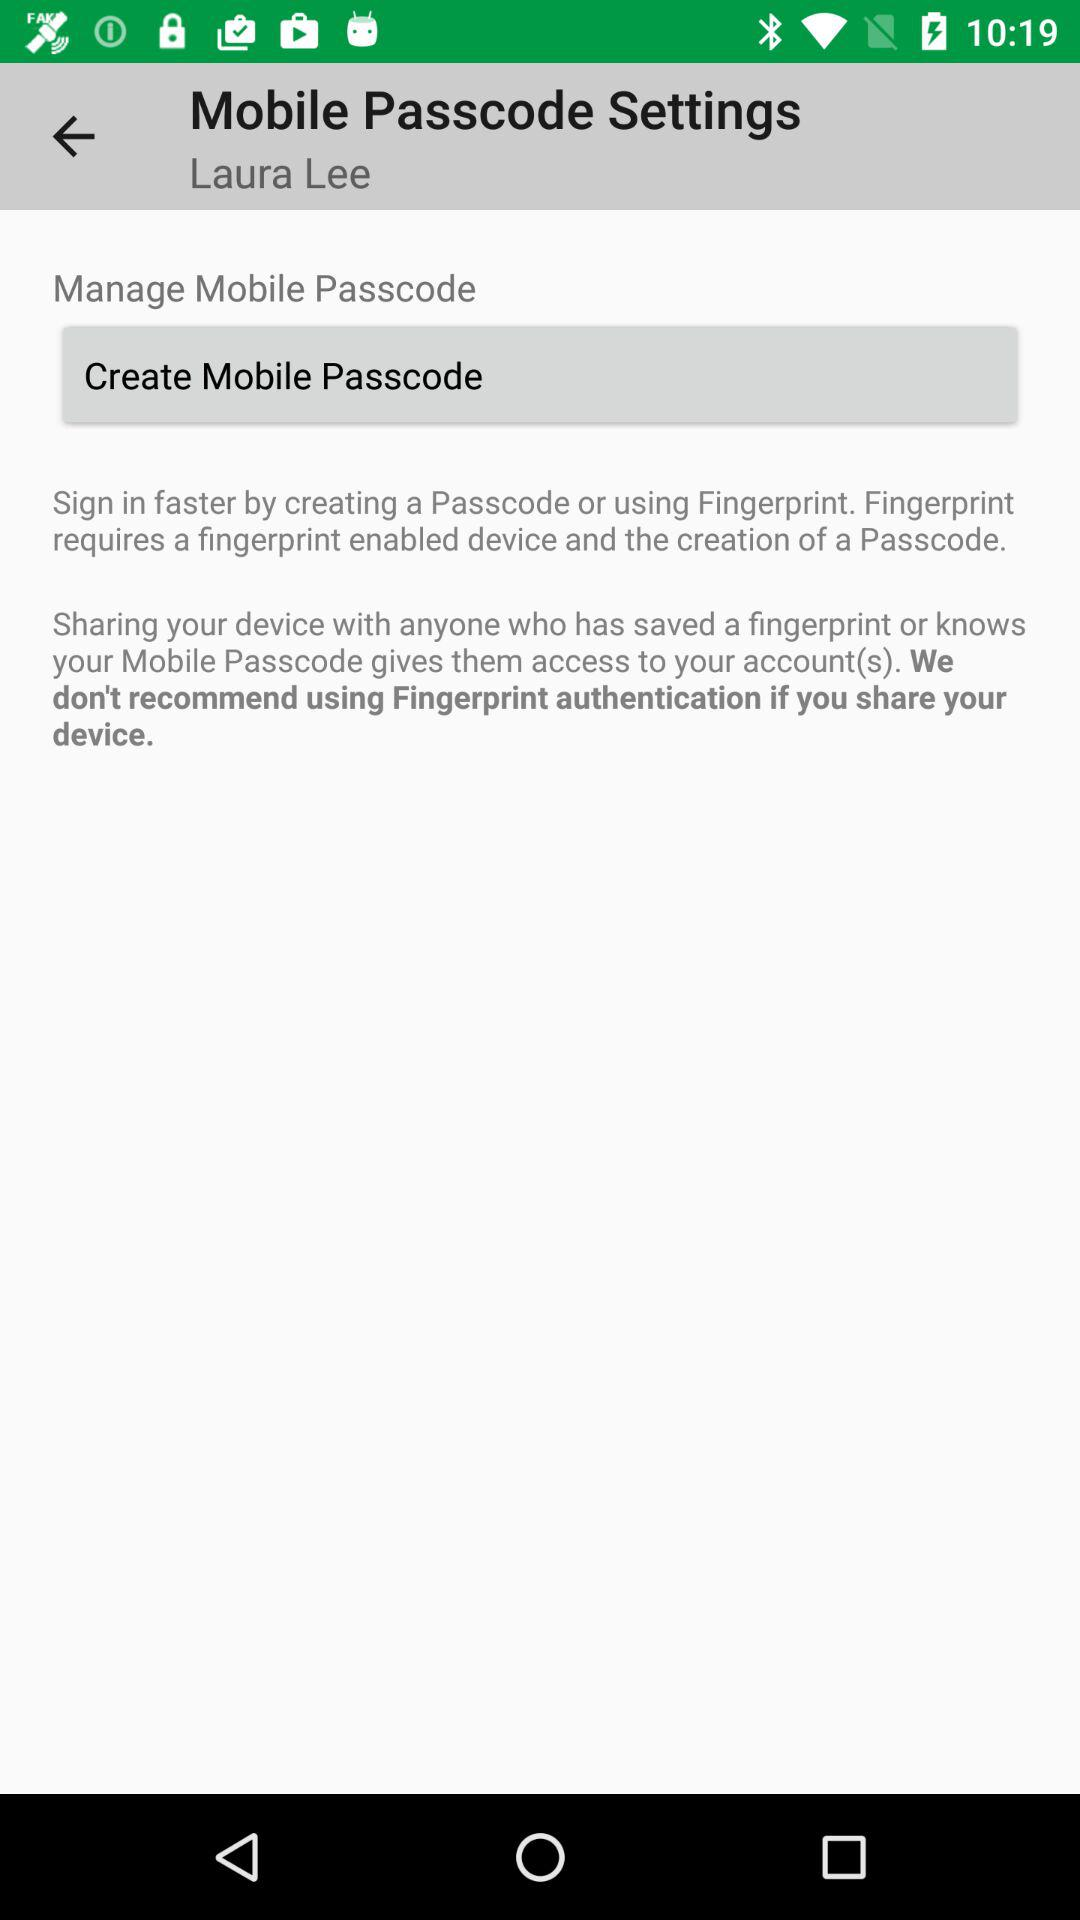What is the requirement for creation of passcode?
When the provided information is insufficient, respond with <no answer>. <no answer> 